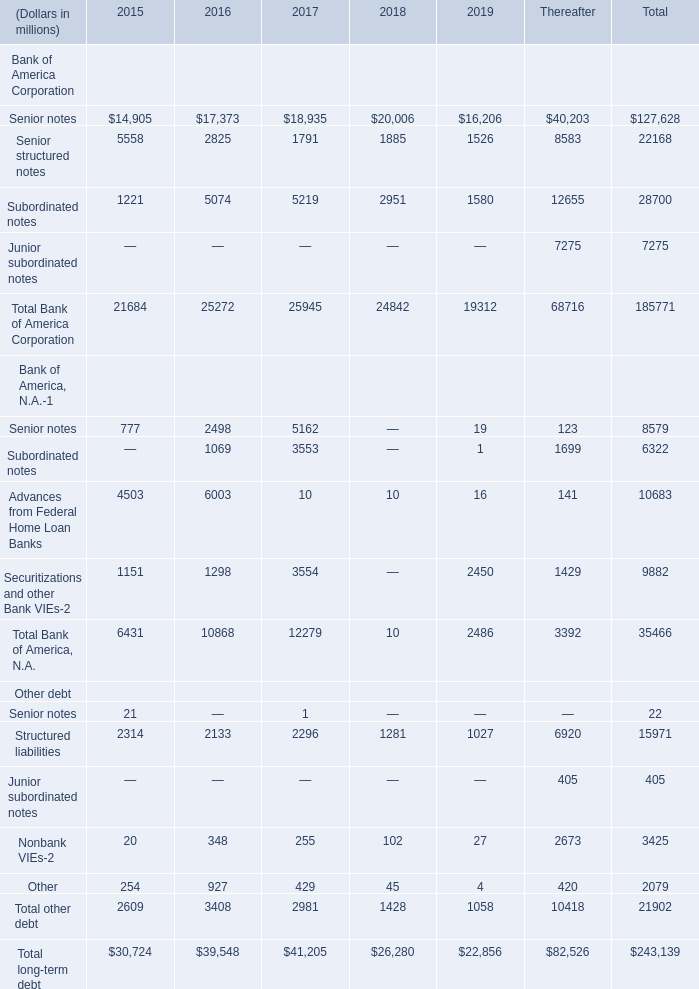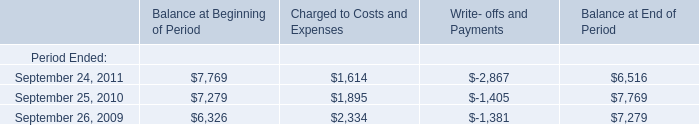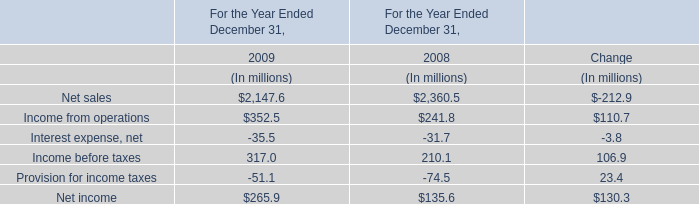What's the sum of September 24, 2011 of Balance at End of Period, and Subordinated notes of 2018 ? 
Computations: (6516.0 + 2951.0)
Answer: 9467.0. 